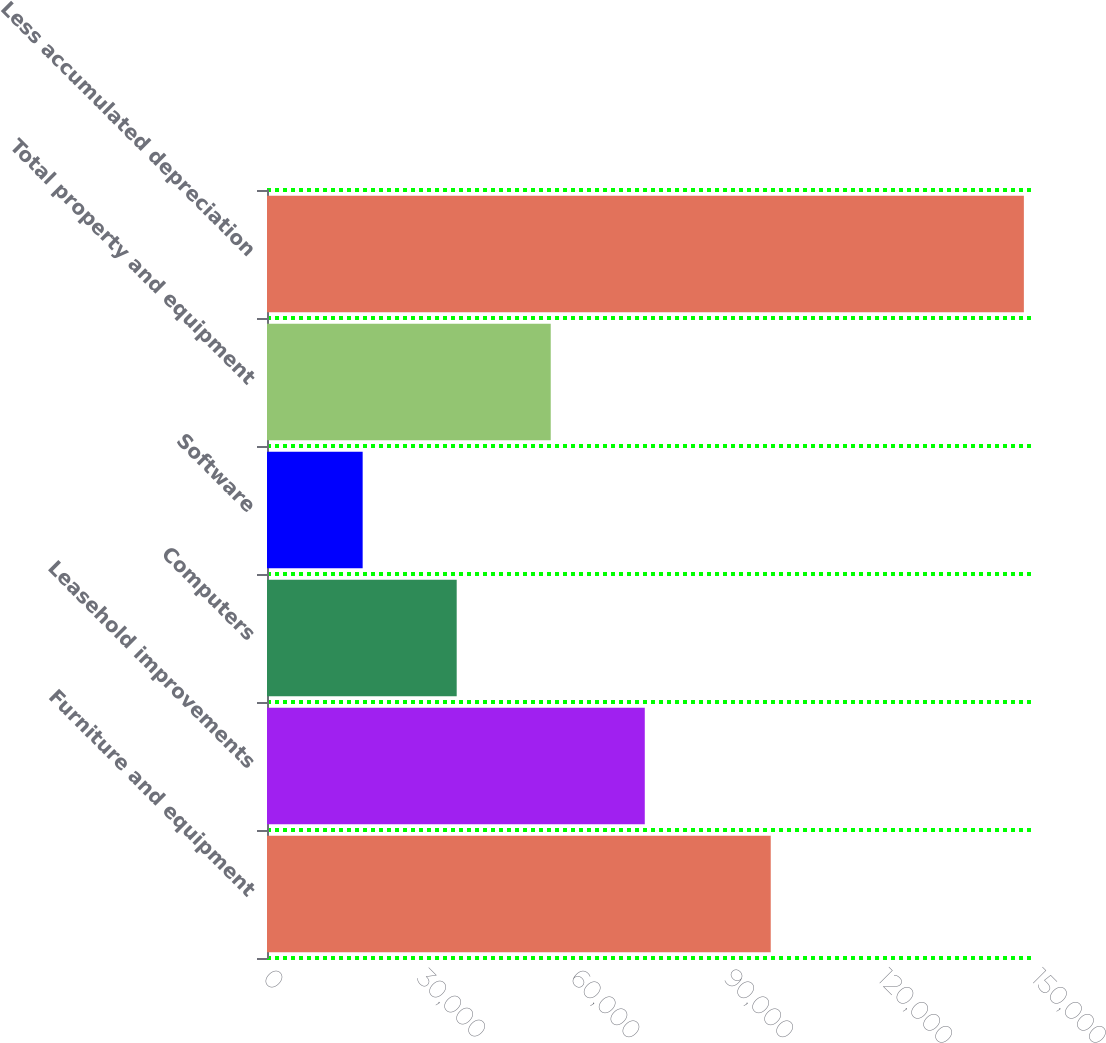Convert chart. <chart><loc_0><loc_0><loc_500><loc_500><bar_chart><fcel>Furniture and equipment<fcel>Leasehold improvements<fcel>Computers<fcel>Software<fcel>Total property and equipment<fcel>Less accumulated depreciation<nl><fcel>98387<fcel>73785.8<fcel>37050.6<fcel>18683<fcel>55418.2<fcel>147826<nl></chart> 